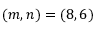<formula> <loc_0><loc_0><loc_500><loc_500>( m , n ) = ( 8 , 6 )</formula> 